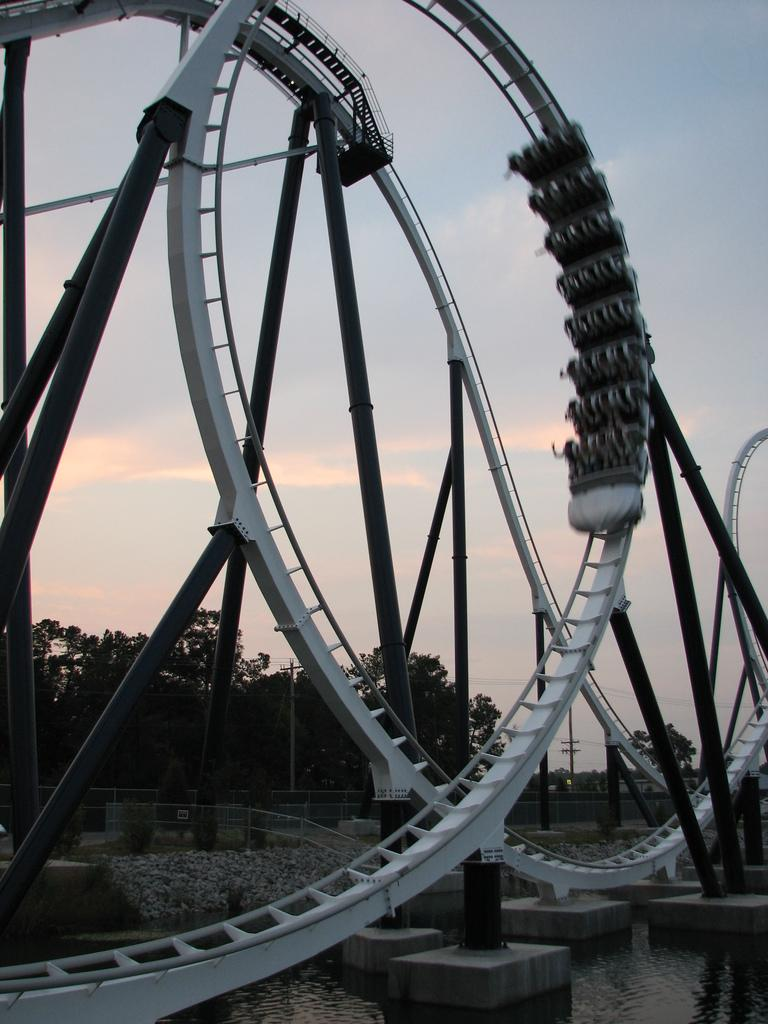What type of ride is featured in the image? There is a roller coaster ride in the image. What structures can be seen supporting the ride? Poles are visible in the image, supporting the roller coaster. What natural element is present in the image? There is water visible in the image. What can be seen in the distance in the image? There are trees in the background of the image. How many apples are hanging from the roller coaster in the image? There are no apples present in the image; it features a roller coaster ride with poles, water, and trees in the background. What type of insurance is being offered for the ride in the image? There is no mention of insurance in the image; it simply shows a roller coaster ride with poles, water, and trees in the background. 